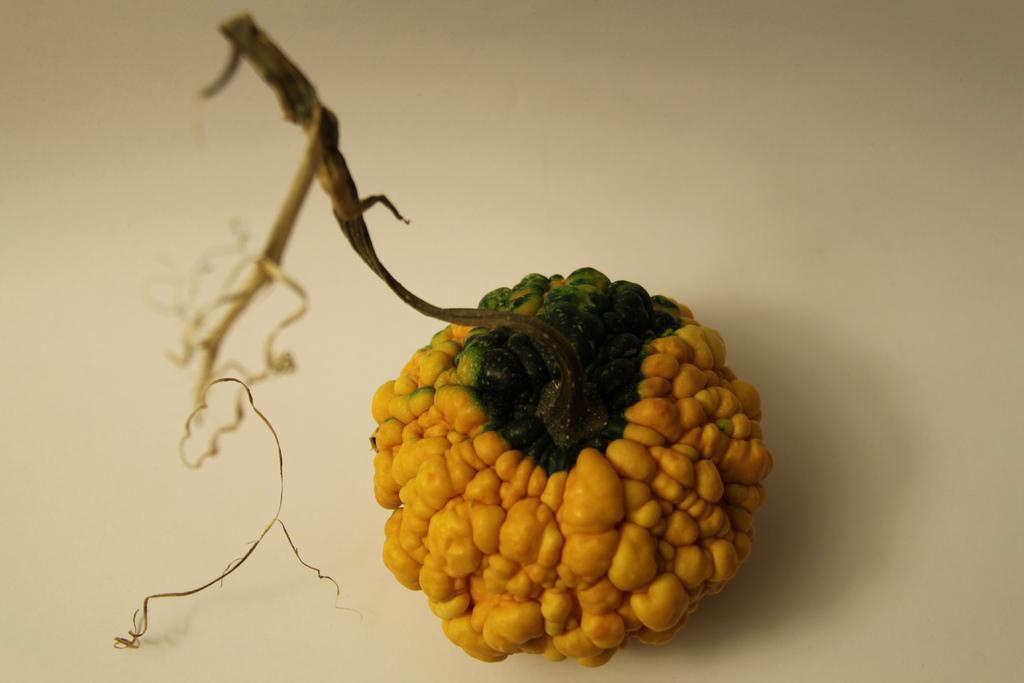In one or two sentences, can you explain what this image depicts? In this picture, we see a fruit in yellow and green color is attached to the stem. In the background, it is white in color. 